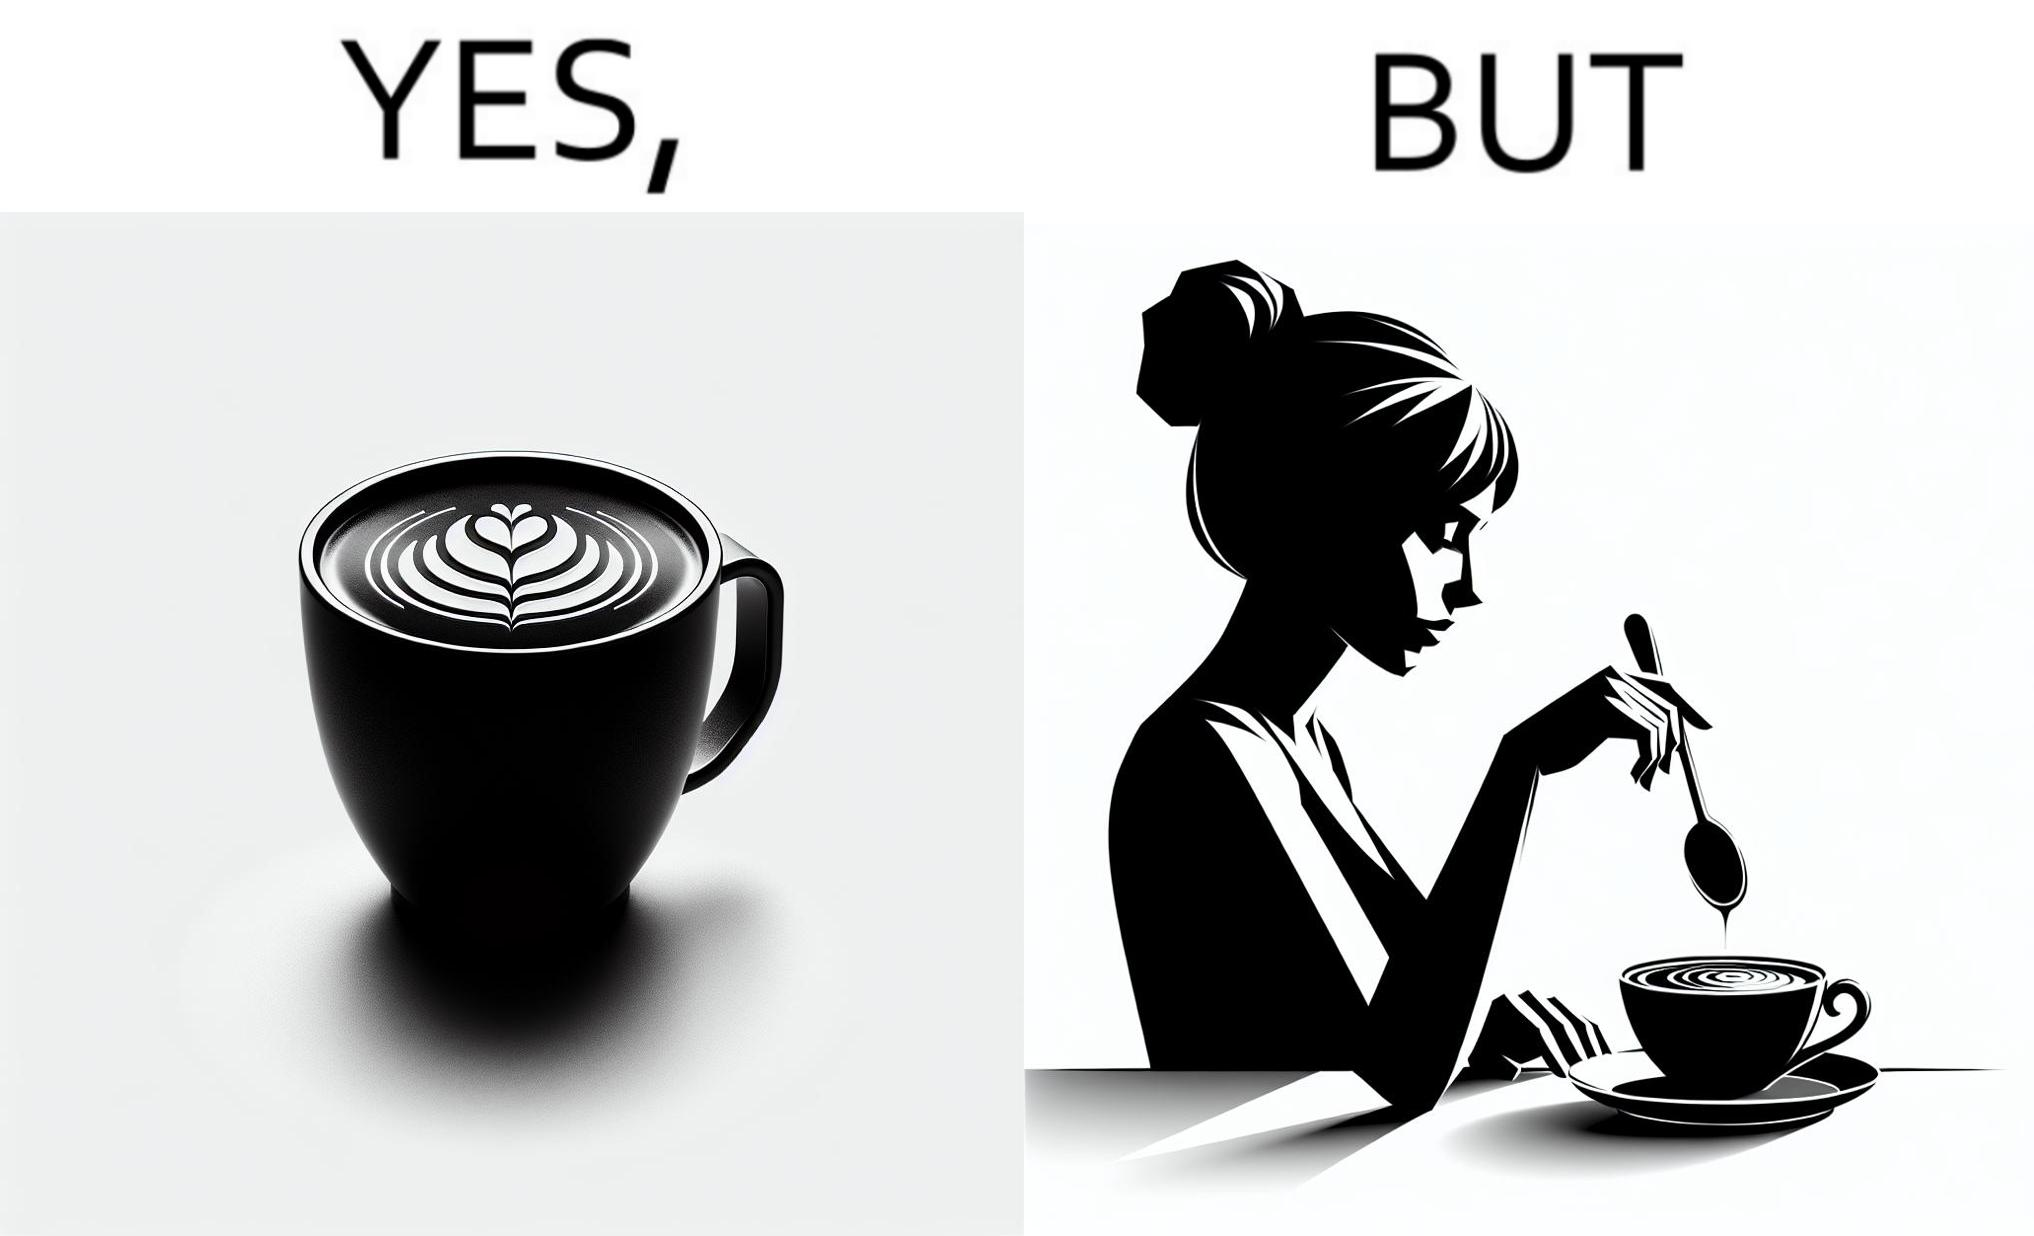What do you see in each half of this image? In the left part of the image: a cup of coffee with latte art on it In the right part of the image: a person stirring the coffee with spoon 